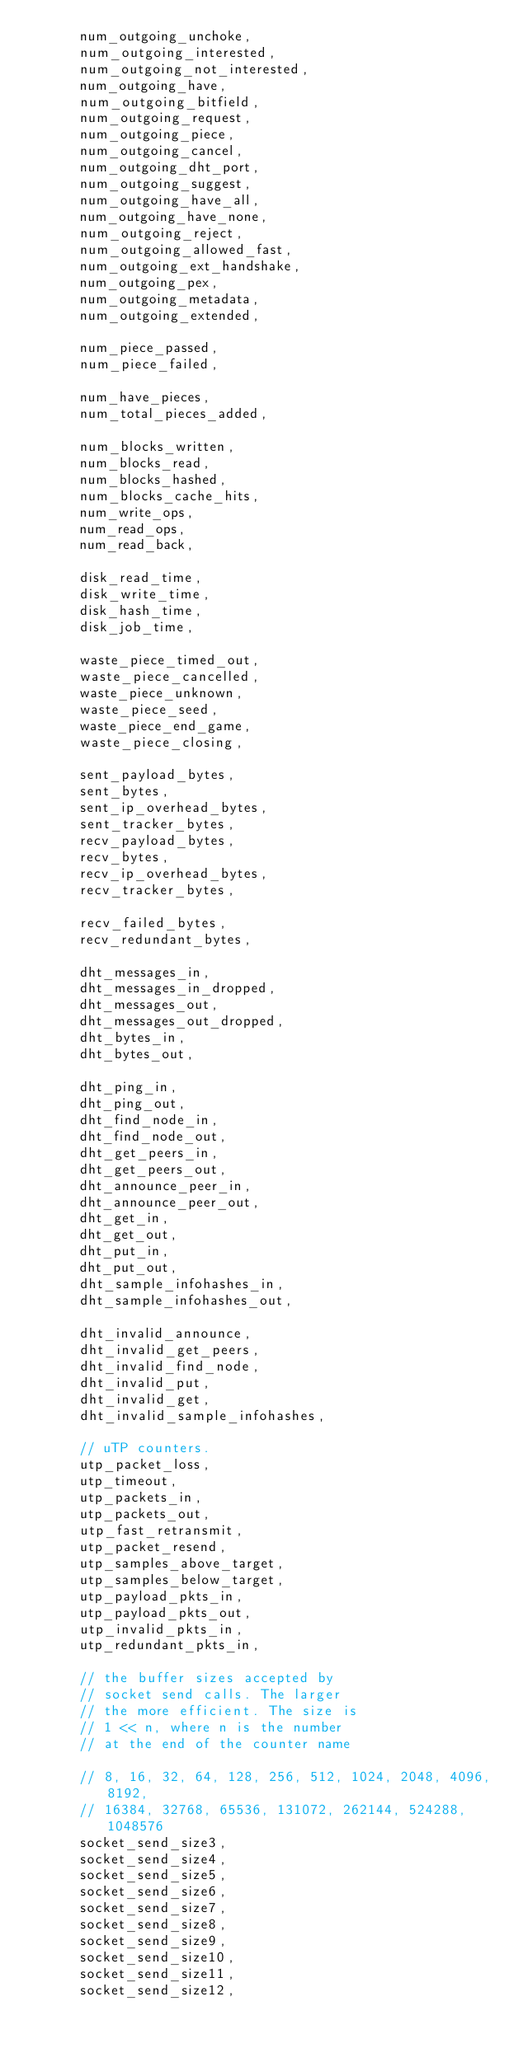Convert code to text. <code><loc_0><loc_0><loc_500><loc_500><_C++_>			num_outgoing_unchoke,
			num_outgoing_interested,
			num_outgoing_not_interested,
			num_outgoing_have,
			num_outgoing_bitfield,
			num_outgoing_request,
			num_outgoing_piece,
			num_outgoing_cancel,
			num_outgoing_dht_port,
			num_outgoing_suggest,
			num_outgoing_have_all,
			num_outgoing_have_none,
			num_outgoing_reject,
			num_outgoing_allowed_fast,
			num_outgoing_ext_handshake,
			num_outgoing_pex,
			num_outgoing_metadata,
			num_outgoing_extended,

			num_piece_passed,
			num_piece_failed,

			num_have_pieces,
			num_total_pieces_added,

			num_blocks_written,
			num_blocks_read,
			num_blocks_hashed,
			num_blocks_cache_hits,
			num_write_ops,
			num_read_ops,
			num_read_back,

			disk_read_time,
			disk_write_time,
			disk_hash_time,
			disk_job_time,

			waste_piece_timed_out,
			waste_piece_cancelled,
			waste_piece_unknown,
			waste_piece_seed,
			waste_piece_end_game,
			waste_piece_closing,

			sent_payload_bytes,
			sent_bytes,
			sent_ip_overhead_bytes,
			sent_tracker_bytes,
			recv_payload_bytes,
			recv_bytes,
			recv_ip_overhead_bytes,
			recv_tracker_bytes,

			recv_failed_bytes,
			recv_redundant_bytes,

			dht_messages_in,
			dht_messages_in_dropped,
			dht_messages_out,
			dht_messages_out_dropped,
			dht_bytes_in,
			dht_bytes_out,

			dht_ping_in,
			dht_ping_out,
			dht_find_node_in,
			dht_find_node_out,
			dht_get_peers_in,
			dht_get_peers_out,
			dht_announce_peer_in,
			dht_announce_peer_out,
			dht_get_in,
			dht_get_out,
			dht_put_in,
			dht_put_out,
			dht_sample_infohashes_in,
			dht_sample_infohashes_out,

			dht_invalid_announce,
			dht_invalid_get_peers,
			dht_invalid_find_node,
			dht_invalid_put,
			dht_invalid_get,
			dht_invalid_sample_infohashes,

			// uTP counters.
			utp_packet_loss,
			utp_timeout,
			utp_packets_in,
			utp_packets_out,
			utp_fast_retransmit,
			utp_packet_resend,
			utp_samples_above_target,
			utp_samples_below_target,
			utp_payload_pkts_in,
			utp_payload_pkts_out,
			utp_invalid_pkts_in,
			utp_redundant_pkts_in,

			// the buffer sizes accepted by
			// socket send calls. The larger
			// the more efficient. The size is
			// 1 << n, where n is the number
			// at the end of the counter name

			// 8, 16, 32, 64, 128, 256, 512, 1024, 2048, 4096, 8192,
			// 16384, 32768, 65536, 131072, 262144, 524288, 1048576
			socket_send_size3,
			socket_send_size4,
			socket_send_size5,
			socket_send_size6,
			socket_send_size7,
			socket_send_size8,
			socket_send_size9,
			socket_send_size10,
			socket_send_size11,
			socket_send_size12,</code> 